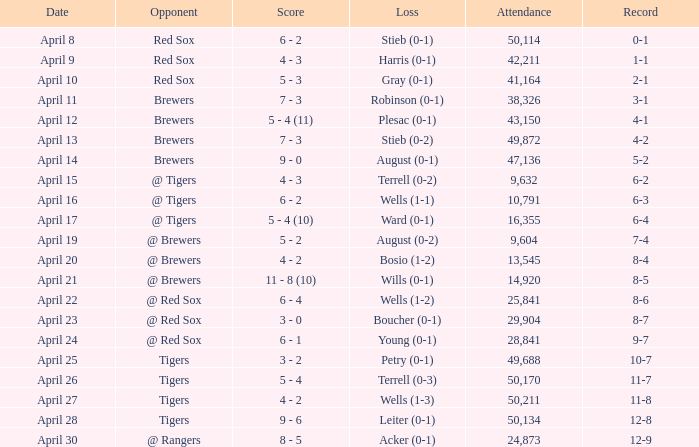Which loss has an attendance greater than 49,688 and 11-8 as the record? Wells (1-3). 